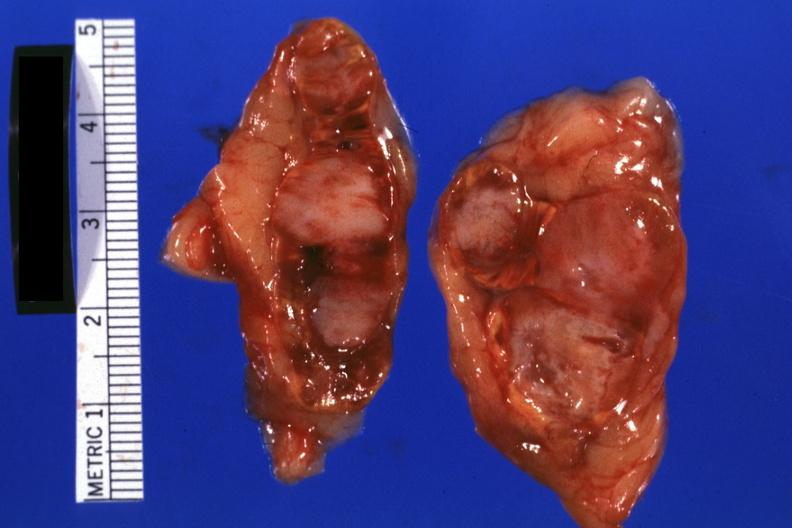s adrenal present?
Answer the question using a single word or phrase. Yes 